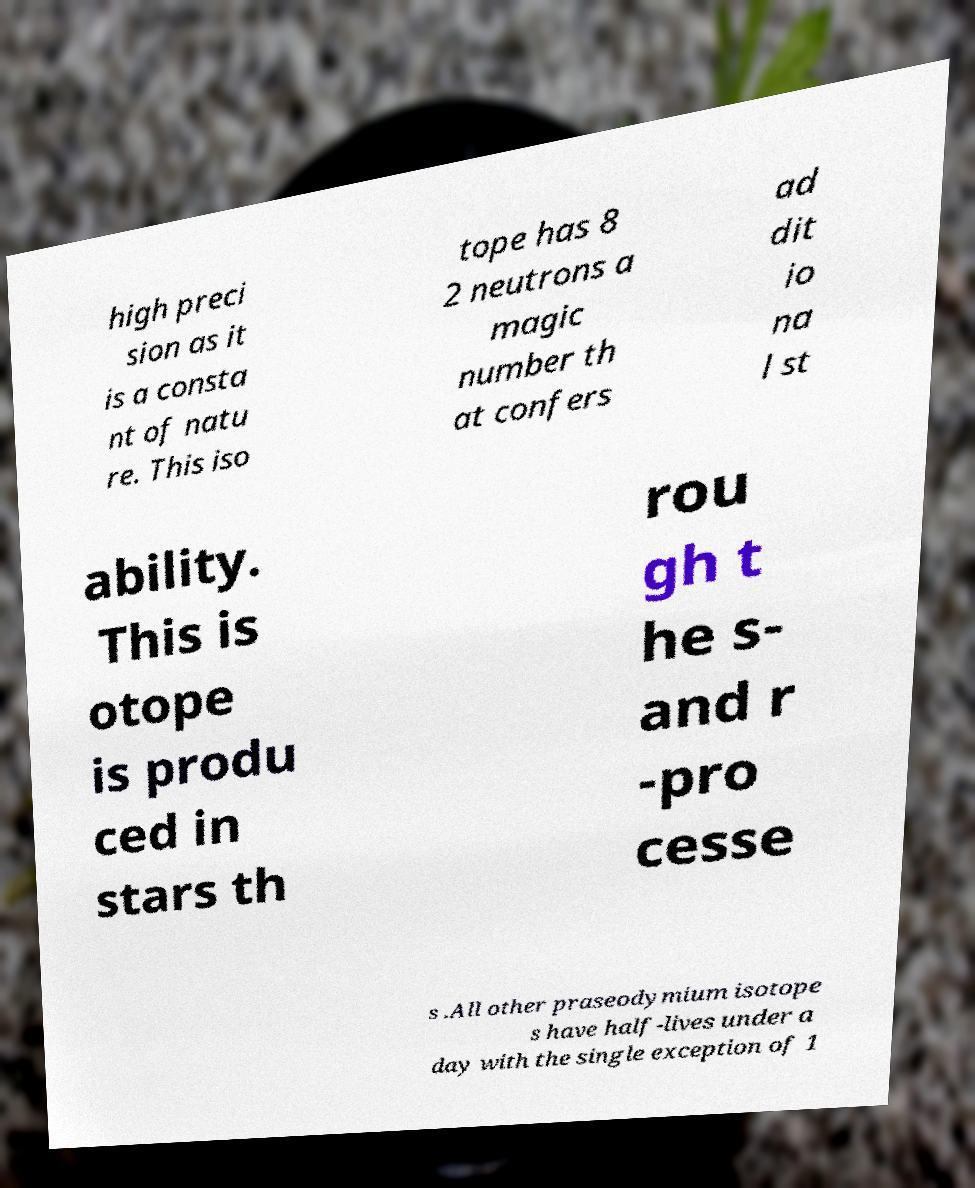Could you assist in decoding the text presented in this image and type it out clearly? high preci sion as it is a consta nt of natu re. This iso tope has 8 2 neutrons a magic number th at confers ad dit io na l st ability. This is otope is produ ced in stars th rou gh t he s- and r -pro cesse s .All other praseodymium isotope s have half-lives under a day with the single exception of 1 